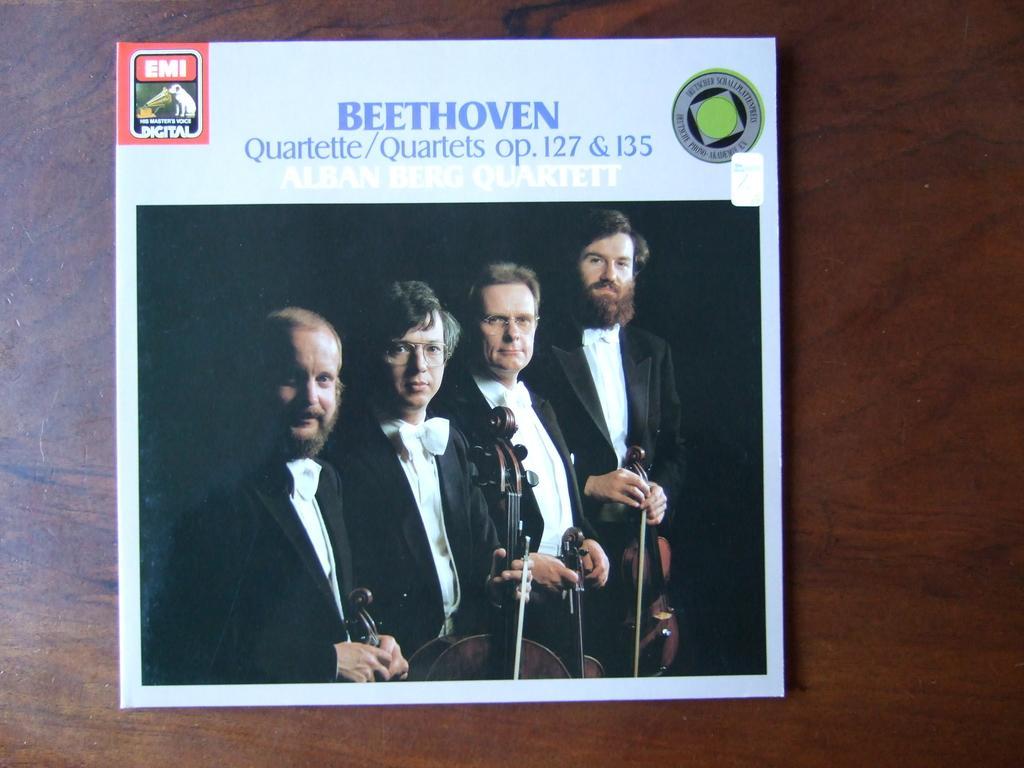How would you summarize this image in a sentence or two? In this image, we can see a flier on the wooden surface contains persons and some text. These persons are wearing clothes and holding musical instruments. 